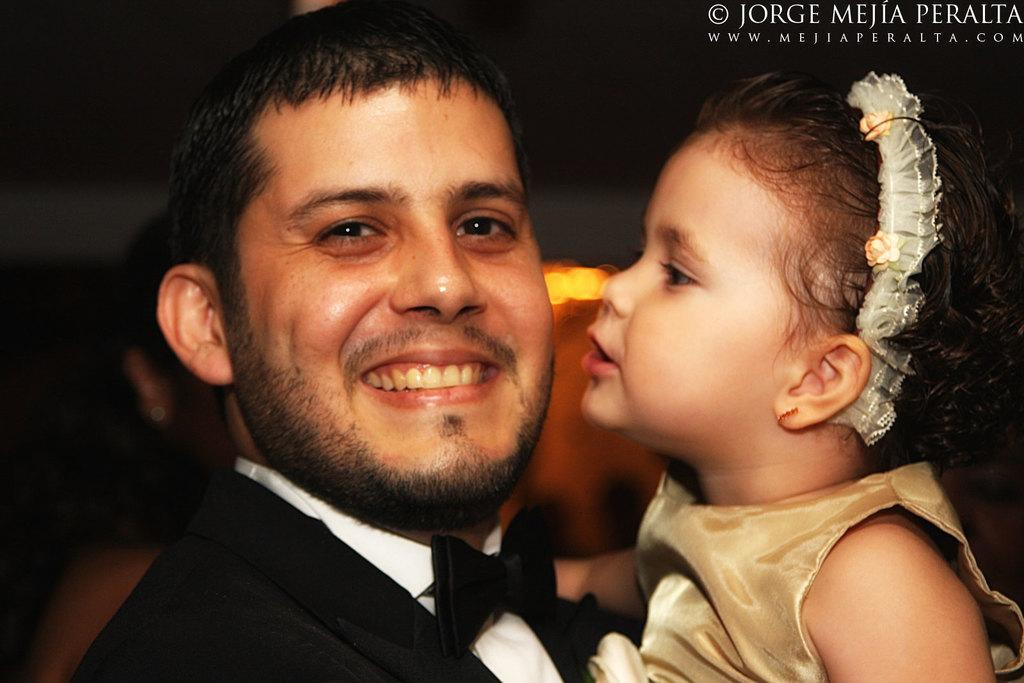What is the main subject of the image? The main subject of the image is a man. What is the man doing in the image? The man is standing and holding a girl. What is the man wearing in the image? The man is wearing a black coat. What is the man's facial expression in the image? The man is smiling in the image. Can you tell me how many copies of the snake are present in the image? There are no snakes present in the image. What type of need is the man using to hold the girl in the image? The man is not using any need to hold the girl; he is simply holding her with his arms. 